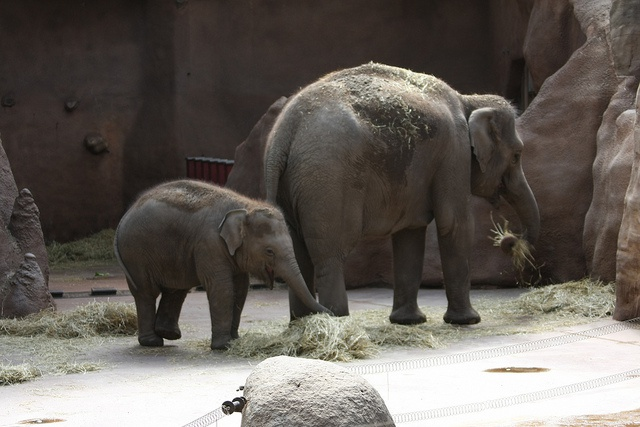Describe the objects in this image and their specific colors. I can see elephant in black, gray, and darkgray tones and elephant in black and gray tones in this image. 